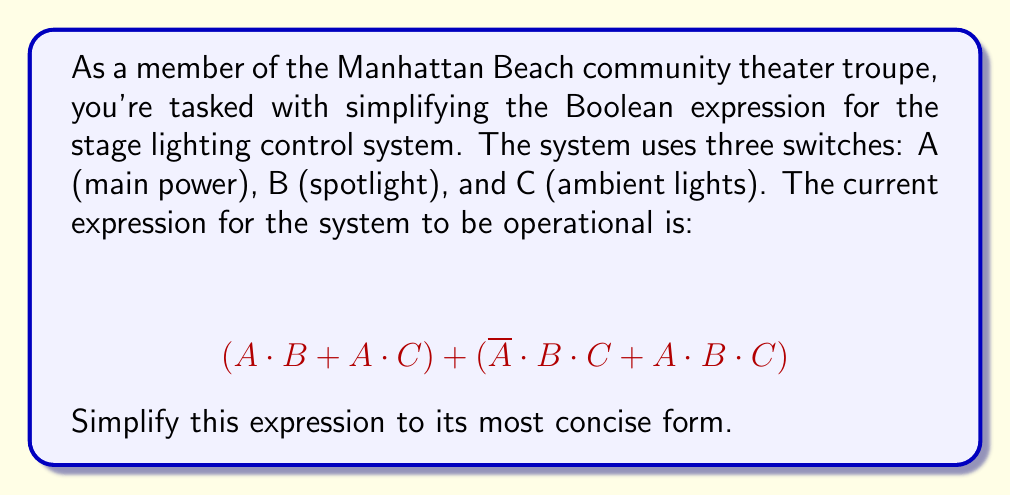What is the answer to this math problem? Let's simplify this Boolean expression step by step:

1) First, let's distribute A in the first parenthesis:
   $$(A \cdot B + A \cdot C) + (\overline{A} \cdot B \cdot C + A \cdot B \cdot C)$$
   $$= A \cdot B + A \cdot C + \overline{A} \cdot B \cdot C + A \cdot B \cdot C$$

2) Now, we can use the absorption law on the first and last terms:
   $$A \cdot B + A \cdot C + \overline{A} \cdot B \cdot C + A \cdot B \cdot C$$
   $$= A \cdot B + A \cdot C + \overline{A} \cdot B \cdot C$$

3) We can factor out B·C from the last two terms:
   $$= A \cdot B + B \cdot C \cdot (A + \overline{A})$$

4) The expression $(A + \overline{A})$ always evaluates to 1, so we can simplify:
   $$= A \cdot B + B \cdot C$$

5) Finally, we can factor out B:
   $$= B \cdot (A + C)$$

This is the most simplified form of the original expression.
Answer: $$B \cdot (A + C)$$ 